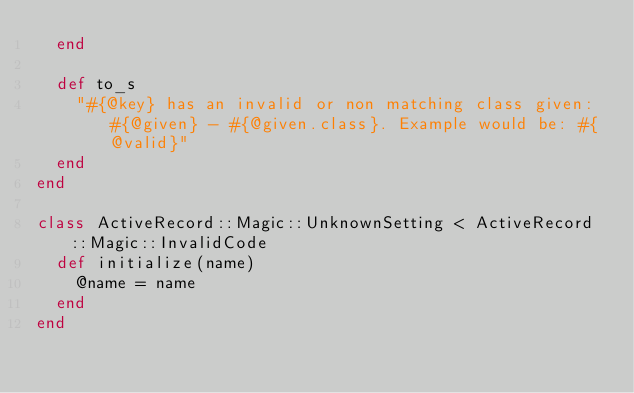<code> <loc_0><loc_0><loc_500><loc_500><_Ruby_>  end
  
  def to_s
    "#{@key} has an invalid or non matching class given: #{@given} - #{@given.class}. Example would be: #{@valid}"
  end
end

class ActiveRecord::Magic::UnknownSetting < ActiveRecord::Magic::InvalidCode
  def initialize(name)
    @name = name
  end
end
</code> 